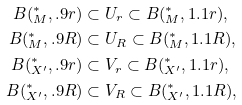<formula> <loc_0><loc_0><loc_500><loc_500>B ( ^ { * } _ { M } , . 9 r ) & \subset U _ { r } \subset B ( ^ { * } _ { M } , 1 . 1 r ) , \\ B ( ^ { * } _ { M } , . 9 R ) & \subset U _ { R } \subset B ( ^ { * } _ { M } , 1 . 1 R ) , \\ B ( ^ { * } _ { X ^ { \prime } } , . 9 r ) & \subset V _ { r } \subset B ( ^ { * } _ { X ^ { \prime } } , 1 . 1 r ) , \\ B ( ^ { * } _ { X ^ { \prime } } , . 9 R ) & \subset V _ { R } \subset B ( ^ { * } _ { X ^ { \prime } } , 1 . 1 R ) ,</formula> 